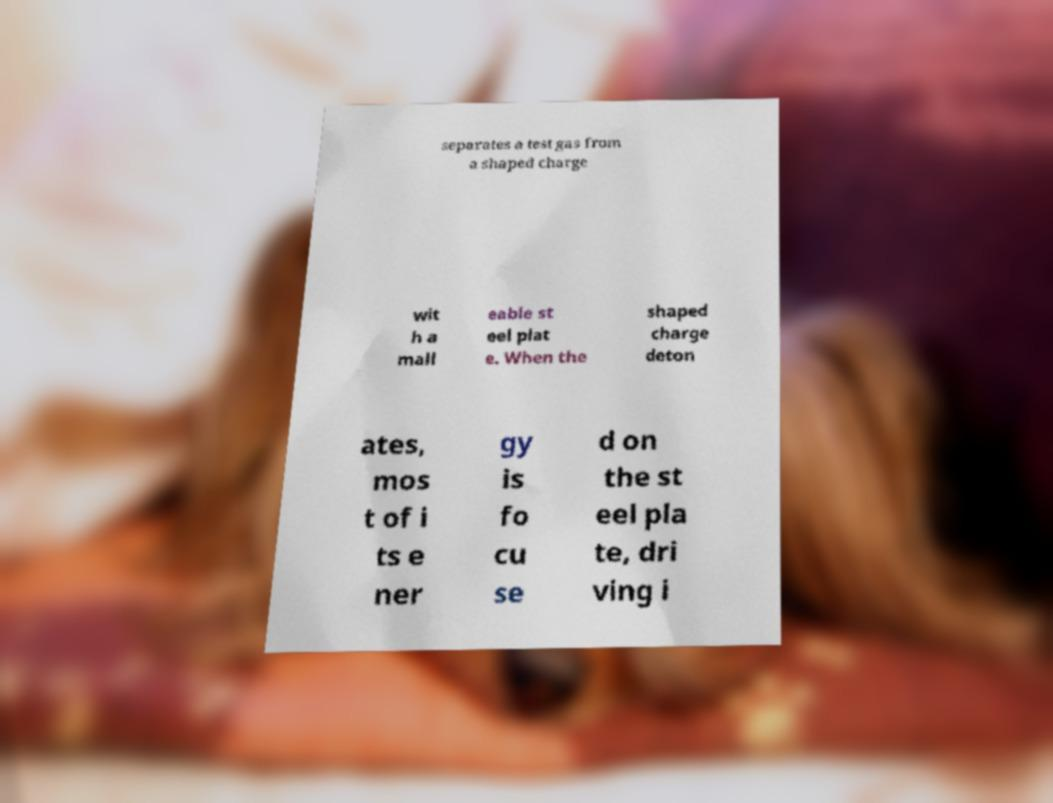Please identify and transcribe the text found in this image. separates a test gas from a shaped charge wit h a mall eable st eel plat e. When the shaped charge deton ates, mos t of i ts e ner gy is fo cu se d on the st eel pla te, dri ving i 